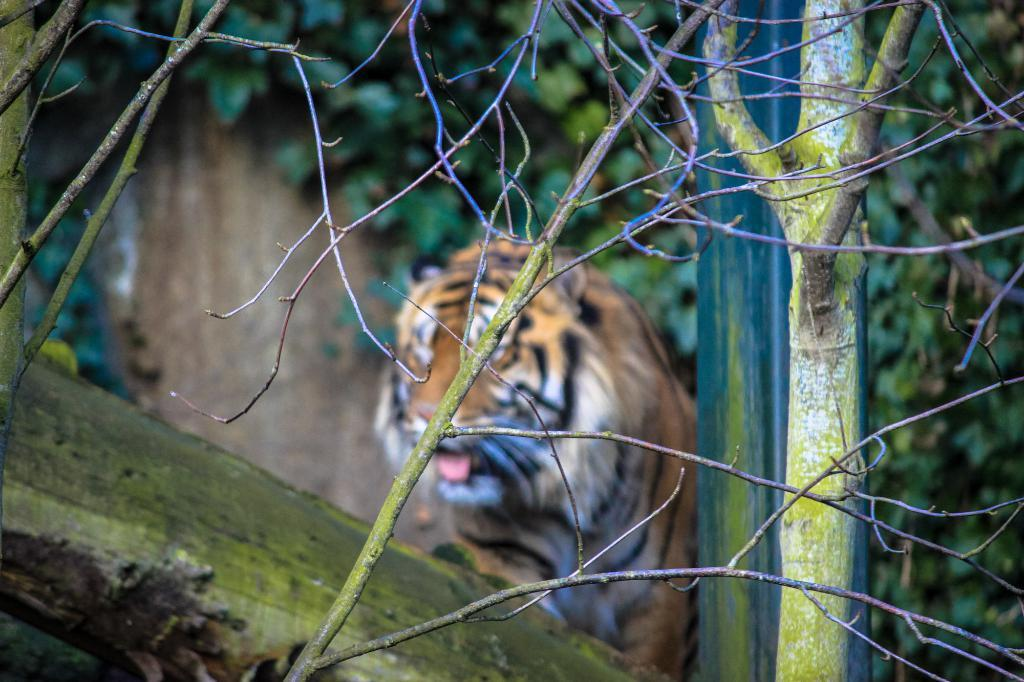What can be observed about the background of the image? The background portion of the picture is blurred. What type of vegetation is present in the image? There are leaves and branches in the image. What animal is featured in the image? There is a tiger in the image. What is the tiger's dad doing in the image? There is no tiger's dad present in the image, as tigers do not have human parents. 